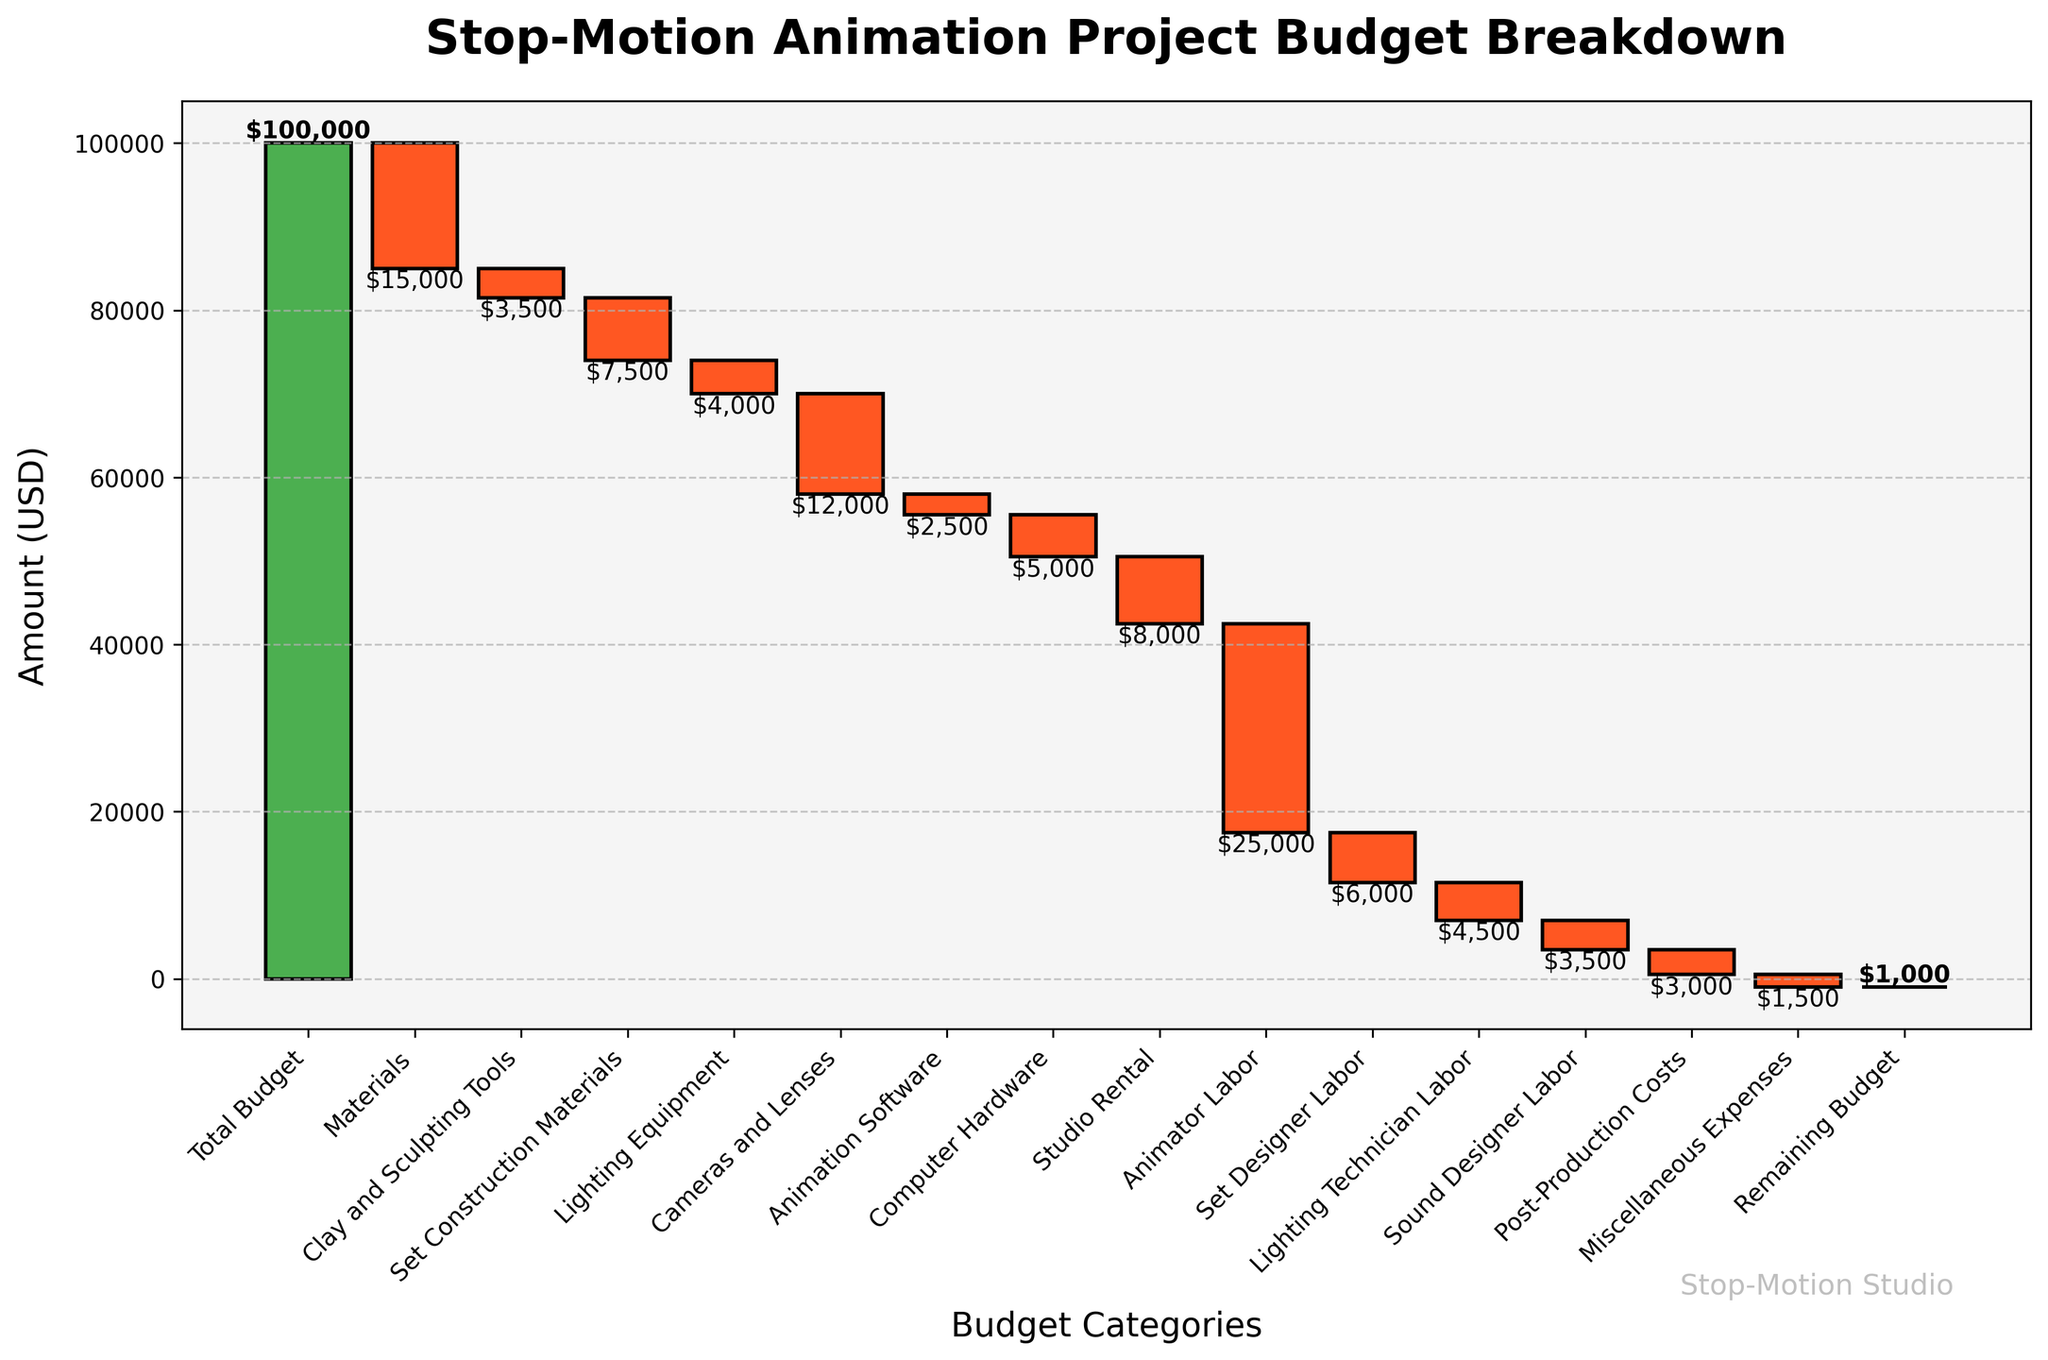What is the total budget for the stop-motion animation project? The figure shows "Total Budget" at the start, indicating the total amount allocated to the project.
Answer: $100,000 How much was spent on set construction materials? Refer to the category "Set Construction Materials" and see the corresponding downward bar, which indicates the cost.
Answer: $7,500 How many categories are there in the budget breakdown? Count the number of categories listed on the x-axis in the figure.
Answer: 14 What is the cumulative cost after accounting for cameras and lenses? Add the amount spent on all categories up to "Cameras and Lenses" from the cumulative sum.
Answer: $43,500 Which category has the highest expenditure? Compare the lengths of all downward bars (indicating negative values) to identify the longest one.
Answer: Animator Labor How much more was spent on animator labor compared to studio rental? Subtract the amount of "Studio Rental" from "Animator Labor" to get the difference.
Answer: $17,000 What is the sum of costs for materials and equipment categories? Add the amounts for materials-related categories: "Materials," "Clay and Sculpting Tools," "Set Construction Materials," "Lighting Equipment," "Cameras and Lenses," "Animation Software," "Computer Hardware."
Answer: $40,500 If you combine the costs for labor categories, what is the total expenditure? Add the amounts for categories related to labor: "Animator Labor," "Set Designer Labor," "Lighting Technician Labor," "Sound Designer Labor."
Answer: $41,000 What is the notable feature about the bar representing the remaining budget? Observe the last bar in the figure; it returns to the x-axis, indicating no money left.
Answer: The bar is at 0 Which category, other than the remaining budget and total budget, has the smallest expenditure? Refer to the smallest downward bar excluding "Total Budget" and "Remaining Budget" categories.
Answer: Miscellaneous Expenses 